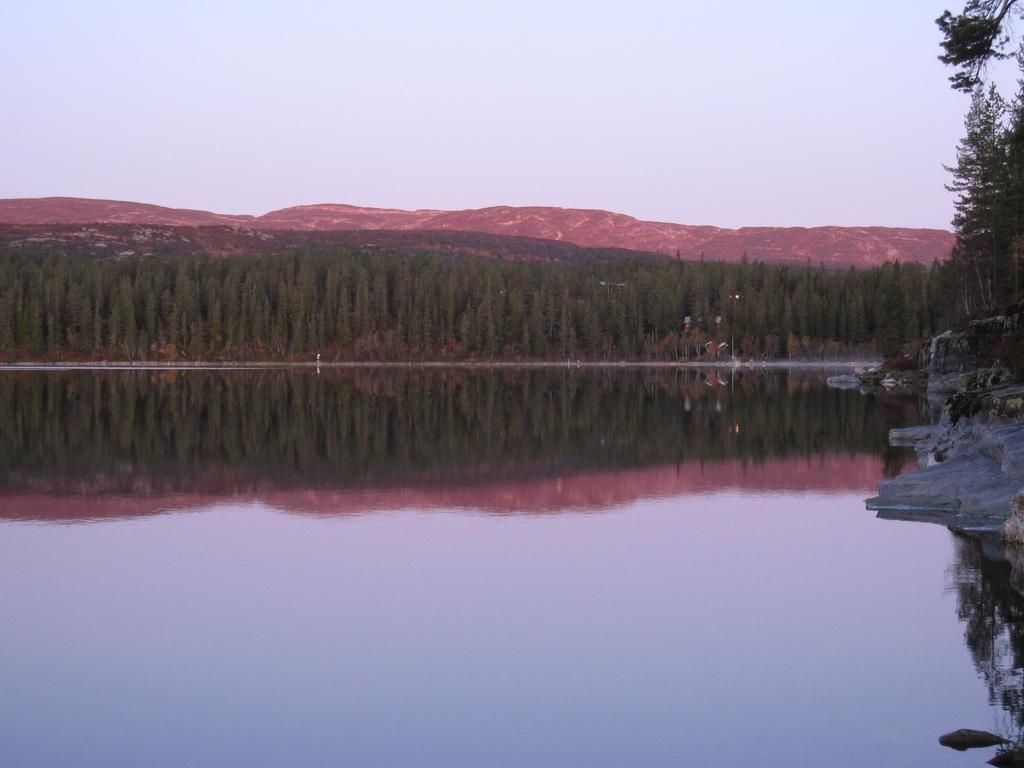What is in the foreground of the image? There is water in the foreground of the image. What can be seen on the right side of the image? There are rocks on the right side of the image. What is visible in the background of the image? There are trees, mountains, and the sky visible in the background of the image. Can you tell me how many people are jumping on the street in the image? There is no street or people jumping present in the image; it features water, rocks, trees, mountains, and the sky. What type of authority figure can be seen in the image? There is no authority figure present in the image. 